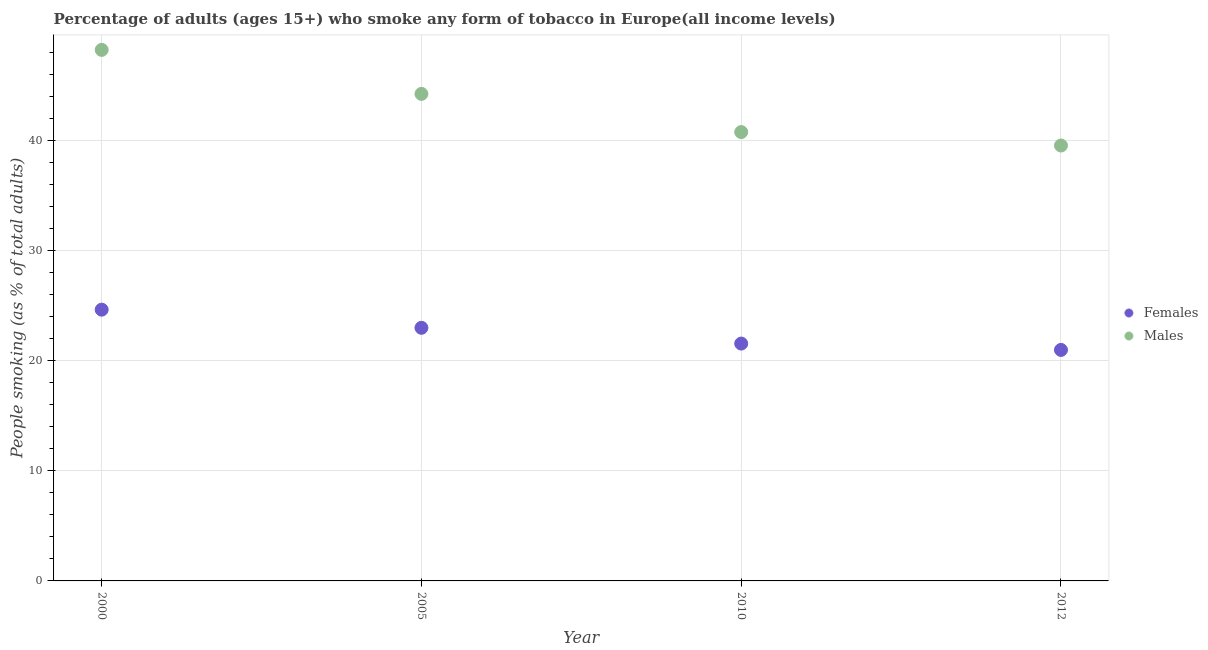How many different coloured dotlines are there?
Your answer should be very brief. 2. Is the number of dotlines equal to the number of legend labels?
Provide a succinct answer. Yes. What is the percentage of males who smoke in 2005?
Give a very brief answer. 44.24. Across all years, what is the maximum percentage of males who smoke?
Keep it short and to the point. 48.24. Across all years, what is the minimum percentage of females who smoke?
Give a very brief answer. 20.98. In which year was the percentage of females who smoke minimum?
Your answer should be very brief. 2012. What is the total percentage of males who smoke in the graph?
Offer a very short reply. 172.81. What is the difference between the percentage of males who smoke in 2005 and that in 2012?
Your response must be concise. 4.69. What is the difference between the percentage of males who smoke in 2010 and the percentage of females who smoke in 2005?
Give a very brief answer. 17.78. What is the average percentage of males who smoke per year?
Offer a very short reply. 43.2. In the year 2010, what is the difference between the percentage of females who smoke and percentage of males who smoke?
Make the answer very short. -19.21. In how many years, is the percentage of males who smoke greater than 22 %?
Give a very brief answer. 4. What is the ratio of the percentage of males who smoke in 2005 to that in 2012?
Offer a very short reply. 1.12. What is the difference between the highest and the second highest percentage of males who smoke?
Keep it short and to the point. 4. What is the difference between the highest and the lowest percentage of males who smoke?
Make the answer very short. 8.69. Is the sum of the percentage of males who smoke in 2005 and 2012 greater than the maximum percentage of females who smoke across all years?
Keep it short and to the point. Yes. Is the percentage of males who smoke strictly less than the percentage of females who smoke over the years?
Provide a short and direct response. No. Where does the legend appear in the graph?
Provide a short and direct response. Center right. How are the legend labels stacked?
Ensure brevity in your answer.  Vertical. What is the title of the graph?
Your answer should be compact. Percentage of adults (ages 15+) who smoke any form of tobacco in Europe(all income levels). Does "Private creditors" appear as one of the legend labels in the graph?
Your response must be concise. No. What is the label or title of the X-axis?
Your response must be concise. Year. What is the label or title of the Y-axis?
Offer a very short reply. People smoking (as % of total adults). What is the People smoking (as % of total adults) in Females in 2000?
Your answer should be very brief. 24.64. What is the People smoking (as % of total adults) of Males in 2000?
Keep it short and to the point. 48.24. What is the People smoking (as % of total adults) in Females in 2005?
Offer a terse response. 22.99. What is the People smoking (as % of total adults) in Males in 2005?
Offer a terse response. 44.24. What is the People smoking (as % of total adults) of Females in 2010?
Offer a terse response. 21.56. What is the People smoking (as % of total adults) of Males in 2010?
Your response must be concise. 40.77. What is the People smoking (as % of total adults) of Females in 2012?
Make the answer very short. 20.98. What is the People smoking (as % of total adults) of Males in 2012?
Provide a short and direct response. 39.55. Across all years, what is the maximum People smoking (as % of total adults) of Females?
Give a very brief answer. 24.64. Across all years, what is the maximum People smoking (as % of total adults) of Males?
Your answer should be very brief. 48.24. Across all years, what is the minimum People smoking (as % of total adults) of Females?
Your response must be concise. 20.98. Across all years, what is the minimum People smoking (as % of total adults) of Males?
Your answer should be compact. 39.55. What is the total People smoking (as % of total adults) in Females in the graph?
Ensure brevity in your answer.  90.18. What is the total People smoking (as % of total adults) in Males in the graph?
Offer a very short reply. 172.81. What is the difference between the People smoking (as % of total adults) of Females in 2000 and that in 2005?
Make the answer very short. 1.65. What is the difference between the People smoking (as % of total adults) in Males in 2000 and that in 2005?
Provide a succinct answer. 4. What is the difference between the People smoking (as % of total adults) in Females in 2000 and that in 2010?
Keep it short and to the point. 3.08. What is the difference between the People smoking (as % of total adults) in Males in 2000 and that in 2010?
Keep it short and to the point. 7.47. What is the difference between the People smoking (as % of total adults) in Females in 2000 and that in 2012?
Make the answer very short. 3.66. What is the difference between the People smoking (as % of total adults) in Males in 2000 and that in 2012?
Your answer should be very brief. 8.69. What is the difference between the People smoking (as % of total adults) in Females in 2005 and that in 2010?
Provide a short and direct response. 1.43. What is the difference between the People smoking (as % of total adults) of Males in 2005 and that in 2010?
Provide a short and direct response. 3.47. What is the difference between the People smoking (as % of total adults) in Females in 2005 and that in 2012?
Give a very brief answer. 2.01. What is the difference between the People smoking (as % of total adults) of Males in 2005 and that in 2012?
Provide a short and direct response. 4.69. What is the difference between the People smoking (as % of total adults) in Females in 2010 and that in 2012?
Offer a very short reply. 0.58. What is the difference between the People smoking (as % of total adults) of Males in 2010 and that in 2012?
Give a very brief answer. 1.22. What is the difference between the People smoking (as % of total adults) of Females in 2000 and the People smoking (as % of total adults) of Males in 2005?
Provide a short and direct response. -19.6. What is the difference between the People smoking (as % of total adults) of Females in 2000 and the People smoking (as % of total adults) of Males in 2010?
Offer a very short reply. -16.13. What is the difference between the People smoking (as % of total adults) in Females in 2000 and the People smoking (as % of total adults) in Males in 2012?
Provide a short and direct response. -14.91. What is the difference between the People smoking (as % of total adults) of Females in 2005 and the People smoking (as % of total adults) of Males in 2010?
Keep it short and to the point. -17.78. What is the difference between the People smoking (as % of total adults) of Females in 2005 and the People smoking (as % of total adults) of Males in 2012?
Your answer should be very brief. -16.56. What is the difference between the People smoking (as % of total adults) of Females in 2010 and the People smoking (as % of total adults) of Males in 2012?
Provide a succinct answer. -17.99. What is the average People smoking (as % of total adults) of Females per year?
Your answer should be very brief. 22.55. What is the average People smoking (as % of total adults) in Males per year?
Offer a terse response. 43.2. In the year 2000, what is the difference between the People smoking (as % of total adults) of Females and People smoking (as % of total adults) of Males?
Offer a terse response. -23.6. In the year 2005, what is the difference between the People smoking (as % of total adults) of Females and People smoking (as % of total adults) of Males?
Make the answer very short. -21.25. In the year 2010, what is the difference between the People smoking (as % of total adults) of Females and People smoking (as % of total adults) of Males?
Ensure brevity in your answer.  -19.21. In the year 2012, what is the difference between the People smoking (as % of total adults) of Females and People smoking (as % of total adults) of Males?
Provide a short and direct response. -18.57. What is the ratio of the People smoking (as % of total adults) of Females in 2000 to that in 2005?
Offer a very short reply. 1.07. What is the ratio of the People smoking (as % of total adults) in Males in 2000 to that in 2005?
Ensure brevity in your answer.  1.09. What is the ratio of the People smoking (as % of total adults) of Females in 2000 to that in 2010?
Your answer should be compact. 1.14. What is the ratio of the People smoking (as % of total adults) of Males in 2000 to that in 2010?
Ensure brevity in your answer.  1.18. What is the ratio of the People smoking (as % of total adults) in Females in 2000 to that in 2012?
Keep it short and to the point. 1.17. What is the ratio of the People smoking (as % of total adults) of Males in 2000 to that in 2012?
Offer a terse response. 1.22. What is the ratio of the People smoking (as % of total adults) in Females in 2005 to that in 2010?
Ensure brevity in your answer.  1.07. What is the ratio of the People smoking (as % of total adults) of Males in 2005 to that in 2010?
Your response must be concise. 1.09. What is the ratio of the People smoking (as % of total adults) of Females in 2005 to that in 2012?
Make the answer very short. 1.1. What is the ratio of the People smoking (as % of total adults) in Males in 2005 to that in 2012?
Provide a succinct answer. 1.12. What is the ratio of the People smoking (as % of total adults) of Females in 2010 to that in 2012?
Your answer should be very brief. 1.03. What is the ratio of the People smoking (as % of total adults) of Males in 2010 to that in 2012?
Provide a short and direct response. 1.03. What is the difference between the highest and the second highest People smoking (as % of total adults) of Females?
Give a very brief answer. 1.65. What is the difference between the highest and the second highest People smoking (as % of total adults) of Males?
Offer a very short reply. 4. What is the difference between the highest and the lowest People smoking (as % of total adults) in Females?
Your answer should be very brief. 3.66. What is the difference between the highest and the lowest People smoking (as % of total adults) of Males?
Keep it short and to the point. 8.69. 